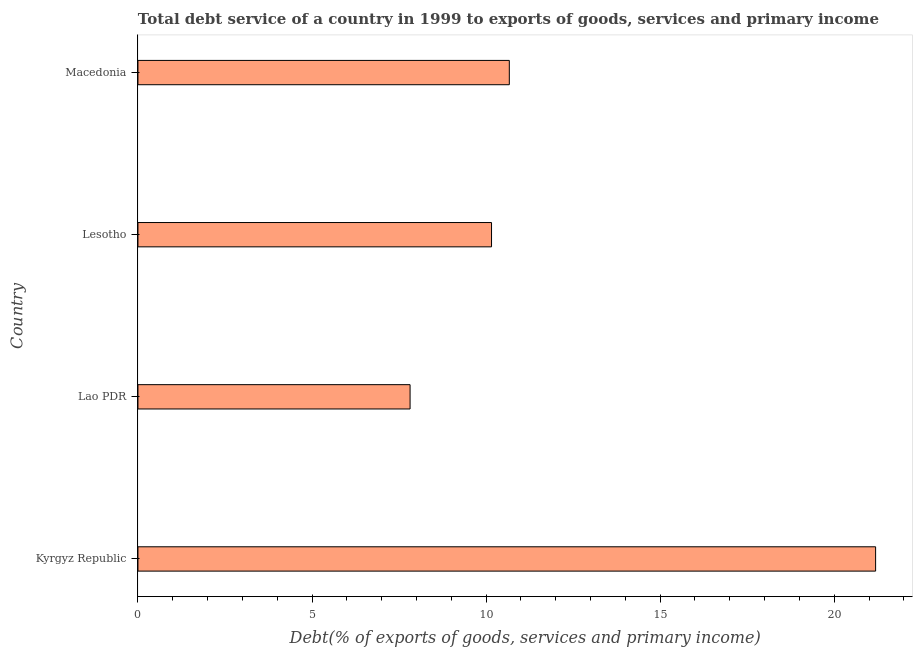Does the graph contain grids?
Offer a very short reply. No. What is the title of the graph?
Offer a very short reply. Total debt service of a country in 1999 to exports of goods, services and primary income. What is the label or title of the X-axis?
Make the answer very short. Debt(% of exports of goods, services and primary income). What is the total debt service in Kyrgyz Republic?
Keep it short and to the point. 21.19. Across all countries, what is the maximum total debt service?
Your response must be concise. 21.19. Across all countries, what is the minimum total debt service?
Make the answer very short. 7.82. In which country was the total debt service maximum?
Your response must be concise. Kyrgyz Republic. In which country was the total debt service minimum?
Your answer should be compact. Lao PDR. What is the sum of the total debt service?
Provide a short and direct response. 49.83. What is the difference between the total debt service in Lao PDR and Lesotho?
Offer a very short reply. -2.34. What is the average total debt service per country?
Provide a succinct answer. 12.46. What is the median total debt service?
Provide a succinct answer. 10.41. Is the difference between the total debt service in Kyrgyz Republic and Lao PDR greater than the difference between any two countries?
Offer a terse response. Yes. What is the difference between the highest and the second highest total debt service?
Offer a very short reply. 10.52. What is the difference between the highest and the lowest total debt service?
Provide a short and direct response. 13.37. In how many countries, is the total debt service greater than the average total debt service taken over all countries?
Offer a terse response. 1. How many countries are there in the graph?
Keep it short and to the point. 4. What is the Debt(% of exports of goods, services and primary income) in Kyrgyz Republic?
Your answer should be compact. 21.19. What is the Debt(% of exports of goods, services and primary income) in Lao PDR?
Give a very brief answer. 7.82. What is the Debt(% of exports of goods, services and primary income) of Lesotho?
Your answer should be very brief. 10.16. What is the Debt(% of exports of goods, services and primary income) in Macedonia?
Provide a short and direct response. 10.67. What is the difference between the Debt(% of exports of goods, services and primary income) in Kyrgyz Republic and Lao PDR?
Your response must be concise. 13.37. What is the difference between the Debt(% of exports of goods, services and primary income) in Kyrgyz Republic and Lesotho?
Provide a short and direct response. 11.03. What is the difference between the Debt(% of exports of goods, services and primary income) in Kyrgyz Republic and Macedonia?
Your answer should be very brief. 10.52. What is the difference between the Debt(% of exports of goods, services and primary income) in Lao PDR and Lesotho?
Offer a terse response. -2.34. What is the difference between the Debt(% of exports of goods, services and primary income) in Lao PDR and Macedonia?
Make the answer very short. -2.85. What is the difference between the Debt(% of exports of goods, services and primary income) in Lesotho and Macedonia?
Give a very brief answer. -0.51. What is the ratio of the Debt(% of exports of goods, services and primary income) in Kyrgyz Republic to that in Lao PDR?
Your response must be concise. 2.71. What is the ratio of the Debt(% of exports of goods, services and primary income) in Kyrgyz Republic to that in Lesotho?
Give a very brief answer. 2.09. What is the ratio of the Debt(% of exports of goods, services and primary income) in Kyrgyz Republic to that in Macedonia?
Offer a very short reply. 1.99. What is the ratio of the Debt(% of exports of goods, services and primary income) in Lao PDR to that in Lesotho?
Keep it short and to the point. 0.77. What is the ratio of the Debt(% of exports of goods, services and primary income) in Lao PDR to that in Macedonia?
Give a very brief answer. 0.73. What is the ratio of the Debt(% of exports of goods, services and primary income) in Lesotho to that in Macedonia?
Provide a short and direct response. 0.95. 